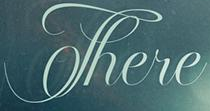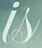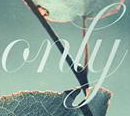What words can you see in these images in sequence, separated by a semicolon? There; is; only 